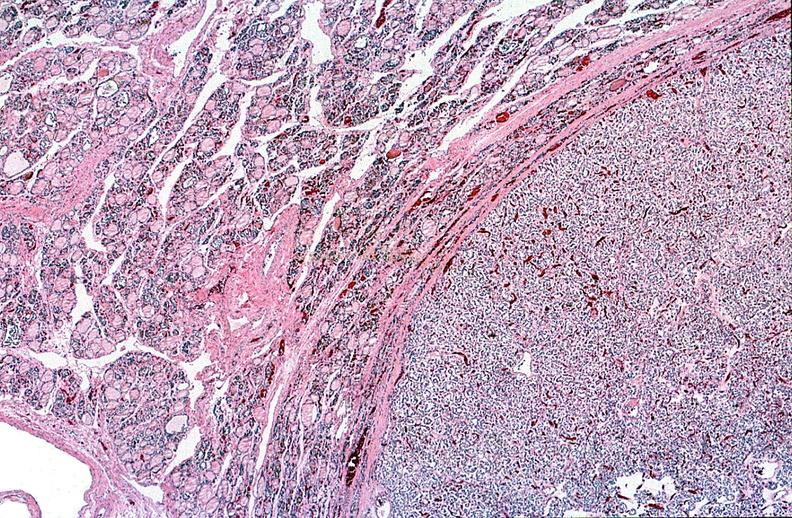does this image show thyroid, follicular ademona?
Answer the question using a single word or phrase. Yes 